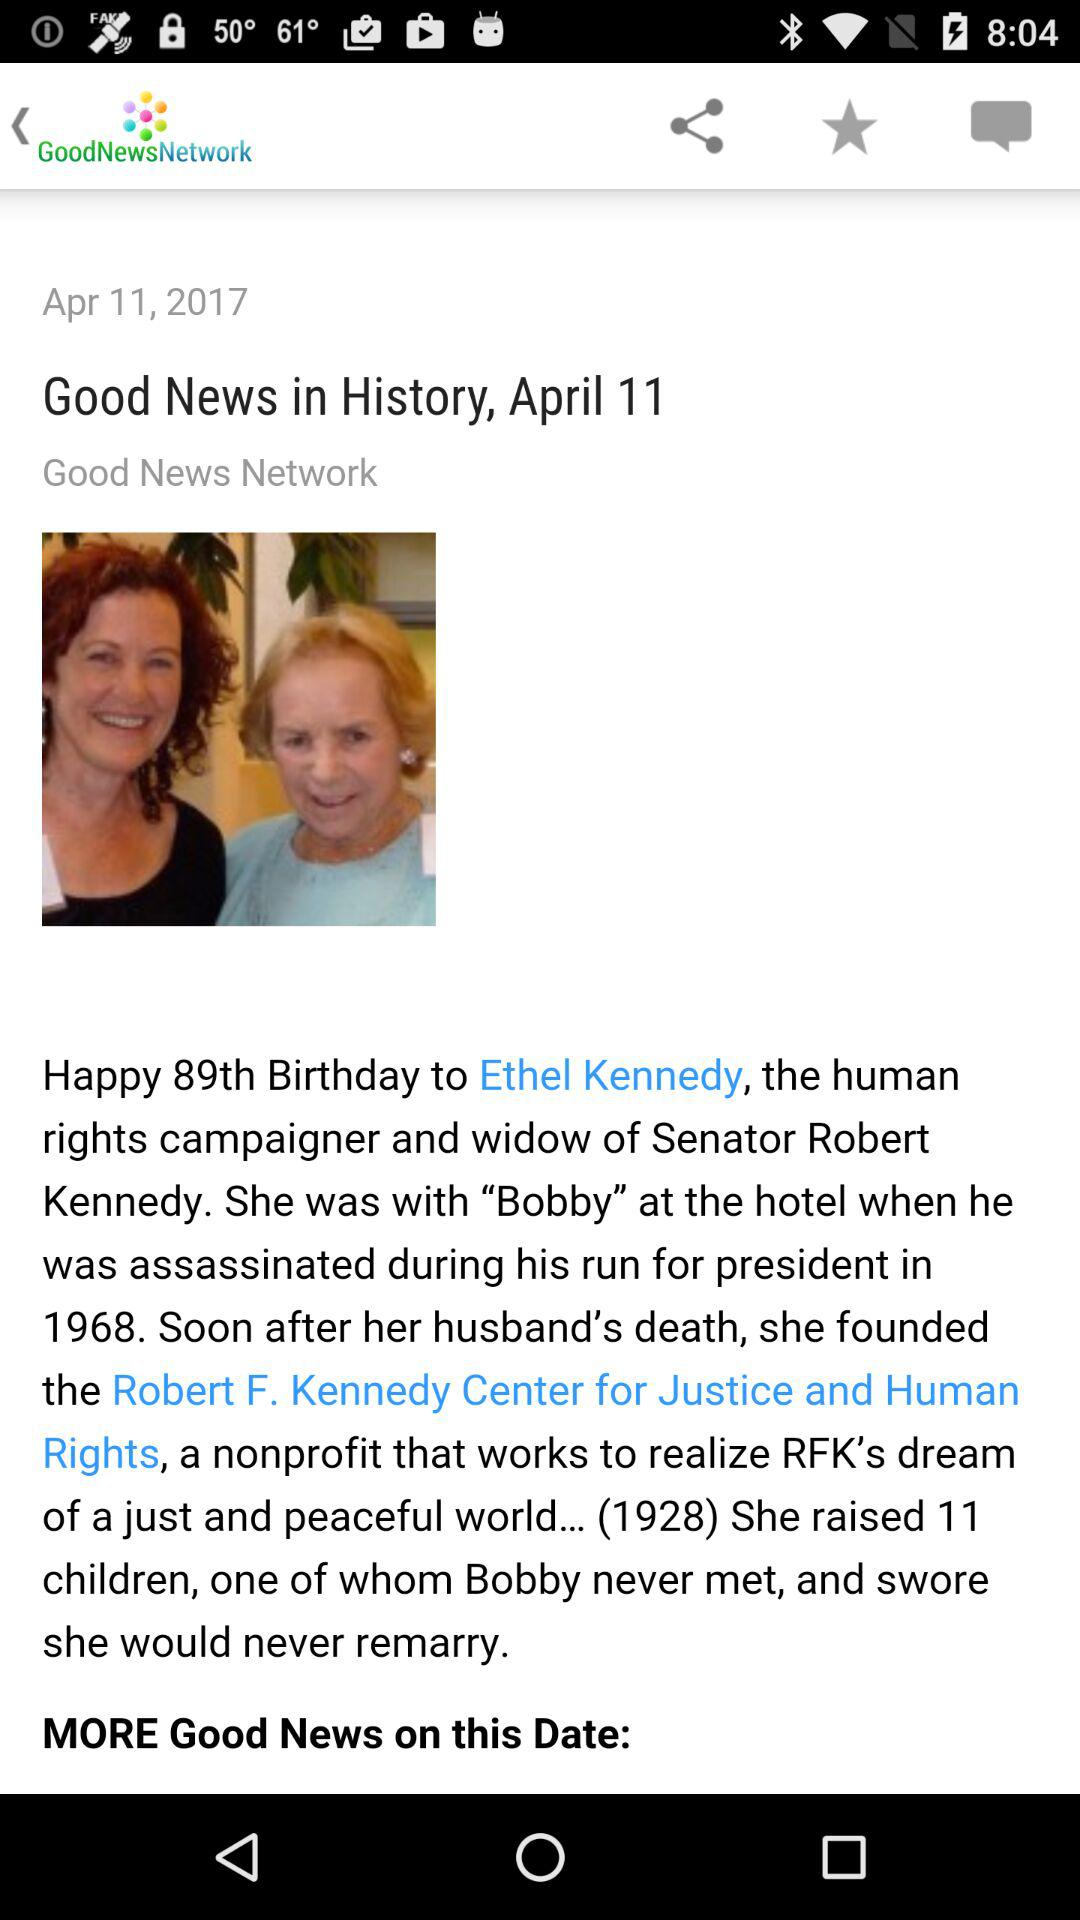How many children did Ethel Kennedy raise?
Answer the question using a single word or phrase. 11 